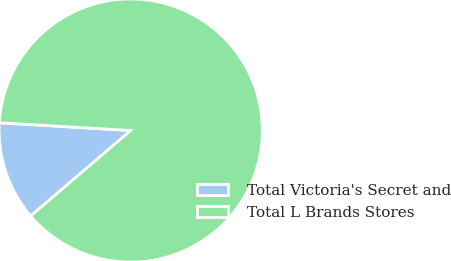Convert chart to OTSL. <chart><loc_0><loc_0><loc_500><loc_500><pie_chart><fcel>Total Victoria's Secret and<fcel>Total L Brands Stores<nl><fcel>12.2%<fcel>87.8%<nl></chart> 